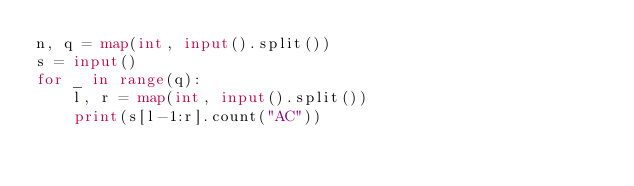<code> <loc_0><loc_0><loc_500><loc_500><_Python_>n, q = map(int, input().split())
s = input()
for _ in range(q):
    l, r = map(int, input().split())
    print(s[l-1:r].count("AC")) </code> 